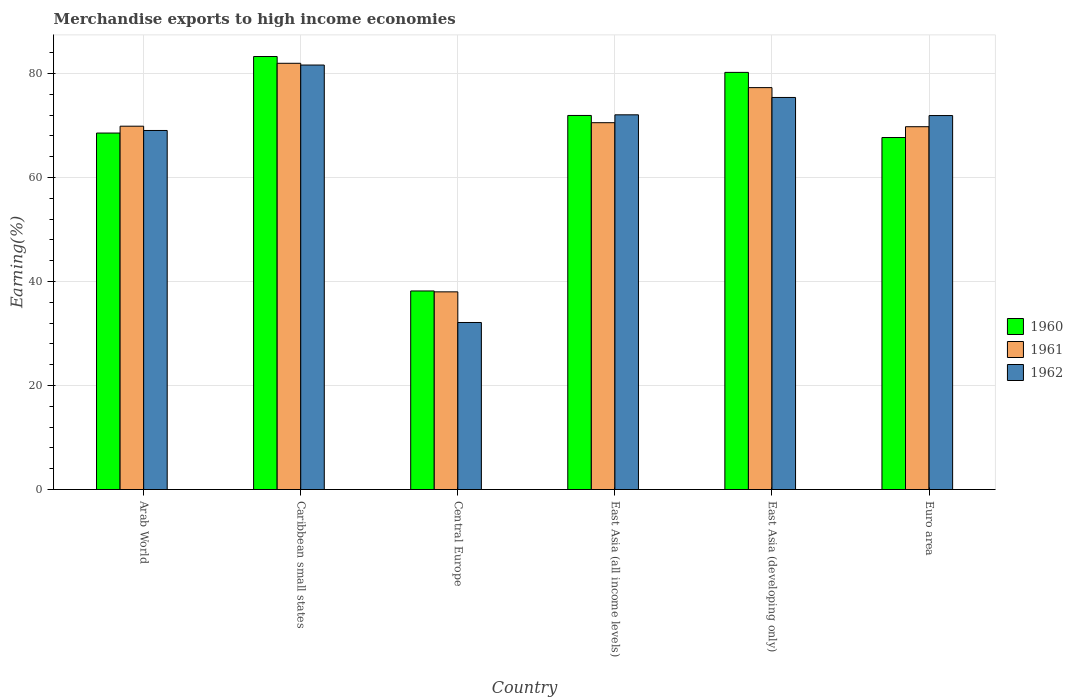How many different coloured bars are there?
Keep it short and to the point. 3. Are the number of bars per tick equal to the number of legend labels?
Keep it short and to the point. Yes. Are the number of bars on each tick of the X-axis equal?
Provide a short and direct response. Yes. How many bars are there on the 3rd tick from the left?
Offer a very short reply. 3. How many bars are there on the 3rd tick from the right?
Your answer should be very brief. 3. What is the label of the 5th group of bars from the left?
Provide a short and direct response. East Asia (developing only). What is the percentage of amount earned from merchandise exports in 1961 in Euro area?
Your answer should be compact. 69.78. Across all countries, what is the maximum percentage of amount earned from merchandise exports in 1960?
Keep it short and to the point. 83.28. Across all countries, what is the minimum percentage of amount earned from merchandise exports in 1962?
Your response must be concise. 32.12. In which country was the percentage of amount earned from merchandise exports in 1960 maximum?
Keep it short and to the point. Caribbean small states. In which country was the percentage of amount earned from merchandise exports in 1960 minimum?
Ensure brevity in your answer.  Central Europe. What is the total percentage of amount earned from merchandise exports in 1962 in the graph?
Ensure brevity in your answer.  402.21. What is the difference between the percentage of amount earned from merchandise exports in 1960 in Arab World and that in Caribbean small states?
Keep it short and to the point. -14.72. What is the difference between the percentage of amount earned from merchandise exports in 1960 in Arab World and the percentage of amount earned from merchandise exports in 1962 in East Asia (developing only)?
Give a very brief answer. -6.84. What is the average percentage of amount earned from merchandise exports in 1960 per country?
Your answer should be compact. 68.32. What is the difference between the percentage of amount earned from merchandise exports of/in 1962 and percentage of amount earned from merchandise exports of/in 1960 in Central Europe?
Offer a very short reply. -6.06. In how many countries, is the percentage of amount earned from merchandise exports in 1960 greater than 60 %?
Your response must be concise. 5. What is the ratio of the percentage of amount earned from merchandise exports in 1962 in East Asia (all income levels) to that in East Asia (developing only)?
Keep it short and to the point. 0.96. Is the difference between the percentage of amount earned from merchandise exports in 1962 in Arab World and East Asia (all income levels) greater than the difference between the percentage of amount earned from merchandise exports in 1960 in Arab World and East Asia (all income levels)?
Offer a terse response. Yes. What is the difference between the highest and the second highest percentage of amount earned from merchandise exports in 1960?
Your response must be concise. -3.05. What is the difference between the highest and the lowest percentage of amount earned from merchandise exports in 1960?
Make the answer very short. 45.09. In how many countries, is the percentage of amount earned from merchandise exports in 1961 greater than the average percentage of amount earned from merchandise exports in 1961 taken over all countries?
Offer a terse response. 5. What does the 1st bar from the left in Euro area represents?
Your response must be concise. 1960. How many bars are there?
Offer a terse response. 18. How many countries are there in the graph?
Provide a short and direct response. 6. Does the graph contain grids?
Offer a very short reply. Yes. How many legend labels are there?
Your answer should be compact. 3. What is the title of the graph?
Your answer should be very brief. Merchandise exports to high income economies. What is the label or title of the X-axis?
Your answer should be compact. Country. What is the label or title of the Y-axis?
Offer a very short reply. Earning(%). What is the Earning(%) in 1960 in Arab World?
Provide a succinct answer. 68.56. What is the Earning(%) of 1961 in Arab World?
Provide a short and direct response. 69.88. What is the Earning(%) of 1962 in Arab World?
Offer a terse response. 69.05. What is the Earning(%) of 1960 in Caribbean small states?
Your response must be concise. 83.28. What is the Earning(%) in 1961 in Caribbean small states?
Ensure brevity in your answer.  81.98. What is the Earning(%) in 1962 in Caribbean small states?
Offer a terse response. 81.64. What is the Earning(%) in 1960 in Central Europe?
Give a very brief answer. 38.19. What is the Earning(%) of 1961 in Central Europe?
Provide a short and direct response. 38.02. What is the Earning(%) in 1962 in Central Europe?
Offer a very short reply. 32.12. What is the Earning(%) of 1960 in East Asia (all income levels)?
Make the answer very short. 71.94. What is the Earning(%) of 1961 in East Asia (all income levels)?
Keep it short and to the point. 70.55. What is the Earning(%) of 1962 in East Asia (all income levels)?
Your response must be concise. 72.07. What is the Earning(%) of 1960 in East Asia (developing only)?
Offer a terse response. 80.23. What is the Earning(%) of 1961 in East Asia (developing only)?
Give a very brief answer. 77.3. What is the Earning(%) of 1962 in East Asia (developing only)?
Provide a short and direct response. 75.4. What is the Earning(%) of 1960 in Euro area?
Offer a terse response. 67.7. What is the Earning(%) in 1961 in Euro area?
Your response must be concise. 69.78. What is the Earning(%) in 1962 in Euro area?
Provide a short and direct response. 71.92. Across all countries, what is the maximum Earning(%) of 1960?
Your answer should be compact. 83.28. Across all countries, what is the maximum Earning(%) of 1961?
Offer a terse response. 81.98. Across all countries, what is the maximum Earning(%) in 1962?
Your answer should be very brief. 81.64. Across all countries, what is the minimum Earning(%) of 1960?
Ensure brevity in your answer.  38.19. Across all countries, what is the minimum Earning(%) of 1961?
Make the answer very short. 38.02. Across all countries, what is the minimum Earning(%) of 1962?
Make the answer very short. 32.12. What is the total Earning(%) in 1960 in the graph?
Offer a very short reply. 409.89. What is the total Earning(%) of 1961 in the graph?
Offer a very short reply. 407.5. What is the total Earning(%) in 1962 in the graph?
Make the answer very short. 402.21. What is the difference between the Earning(%) of 1960 in Arab World and that in Caribbean small states?
Make the answer very short. -14.72. What is the difference between the Earning(%) in 1961 in Arab World and that in Caribbean small states?
Offer a very short reply. -12.1. What is the difference between the Earning(%) of 1962 in Arab World and that in Caribbean small states?
Ensure brevity in your answer.  -12.58. What is the difference between the Earning(%) in 1960 in Arab World and that in Central Europe?
Provide a succinct answer. 30.37. What is the difference between the Earning(%) of 1961 in Arab World and that in Central Europe?
Provide a succinct answer. 31.86. What is the difference between the Earning(%) in 1962 in Arab World and that in Central Europe?
Offer a terse response. 36.93. What is the difference between the Earning(%) of 1960 in Arab World and that in East Asia (all income levels)?
Your answer should be very brief. -3.38. What is the difference between the Earning(%) in 1961 in Arab World and that in East Asia (all income levels)?
Your answer should be compact. -0.67. What is the difference between the Earning(%) in 1962 in Arab World and that in East Asia (all income levels)?
Offer a terse response. -3.01. What is the difference between the Earning(%) of 1960 in Arab World and that in East Asia (developing only)?
Provide a short and direct response. -11.67. What is the difference between the Earning(%) in 1961 in Arab World and that in East Asia (developing only)?
Your answer should be compact. -7.42. What is the difference between the Earning(%) in 1962 in Arab World and that in East Asia (developing only)?
Provide a short and direct response. -6.35. What is the difference between the Earning(%) of 1960 in Arab World and that in Euro area?
Keep it short and to the point. 0.86. What is the difference between the Earning(%) in 1961 in Arab World and that in Euro area?
Provide a succinct answer. 0.1. What is the difference between the Earning(%) of 1962 in Arab World and that in Euro area?
Provide a short and direct response. -2.87. What is the difference between the Earning(%) in 1960 in Caribbean small states and that in Central Europe?
Provide a succinct answer. 45.09. What is the difference between the Earning(%) in 1961 in Caribbean small states and that in Central Europe?
Ensure brevity in your answer.  43.96. What is the difference between the Earning(%) of 1962 in Caribbean small states and that in Central Europe?
Offer a terse response. 49.52. What is the difference between the Earning(%) in 1960 in Caribbean small states and that in East Asia (all income levels)?
Ensure brevity in your answer.  11.34. What is the difference between the Earning(%) in 1961 in Caribbean small states and that in East Asia (all income levels)?
Your response must be concise. 11.42. What is the difference between the Earning(%) in 1962 in Caribbean small states and that in East Asia (all income levels)?
Offer a terse response. 9.57. What is the difference between the Earning(%) of 1960 in Caribbean small states and that in East Asia (developing only)?
Keep it short and to the point. 3.05. What is the difference between the Earning(%) of 1961 in Caribbean small states and that in East Asia (developing only)?
Keep it short and to the point. 4.68. What is the difference between the Earning(%) of 1962 in Caribbean small states and that in East Asia (developing only)?
Ensure brevity in your answer.  6.23. What is the difference between the Earning(%) of 1960 in Caribbean small states and that in Euro area?
Make the answer very short. 15.58. What is the difference between the Earning(%) in 1961 in Caribbean small states and that in Euro area?
Your answer should be very brief. 12.2. What is the difference between the Earning(%) of 1962 in Caribbean small states and that in Euro area?
Offer a very short reply. 9.71. What is the difference between the Earning(%) in 1960 in Central Europe and that in East Asia (all income levels)?
Offer a terse response. -33.75. What is the difference between the Earning(%) of 1961 in Central Europe and that in East Asia (all income levels)?
Your response must be concise. -32.54. What is the difference between the Earning(%) in 1962 in Central Europe and that in East Asia (all income levels)?
Give a very brief answer. -39.94. What is the difference between the Earning(%) in 1960 in Central Europe and that in East Asia (developing only)?
Your answer should be very brief. -42.04. What is the difference between the Earning(%) of 1961 in Central Europe and that in East Asia (developing only)?
Your answer should be compact. -39.28. What is the difference between the Earning(%) in 1962 in Central Europe and that in East Asia (developing only)?
Your response must be concise. -43.28. What is the difference between the Earning(%) in 1960 in Central Europe and that in Euro area?
Provide a succinct answer. -29.51. What is the difference between the Earning(%) in 1961 in Central Europe and that in Euro area?
Give a very brief answer. -31.76. What is the difference between the Earning(%) of 1962 in Central Europe and that in Euro area?
Ensure brevity in your answer.  -39.8. What is the difference between the Earning(%) of 1960 in East Asia (all income levels) and that in East Asia (developing only)?
Your answer should be very brief. -8.29. What is the difference between the Earning(%) in 1961 in East Asia (all income levels) and that in East Asia (developing only)?
Provide a short and direct response. -6.75. What is the difference between the Earning(%) of 1962 in East Asia (all income levels) and that in East Asia (developing only)?
Give a very brief answer. -3.34. What is the difference between the Earning(%) of 1960 in East Asia (all income levels) and that in Euro area?
Your answer should be very brief. 4.24. What is the difference between the Earning(%) of 1961 in East Asia (all income levels) and that in Euro area?
Your response must be concise. 0.77. What is the difference between the Earning(%) in 1962 in East Asia (all income levels) and that in Euro area?
Your answer should be very brief. 0.14. What is the difference between the Earning(%) in 1960 in East Asia (developing only) and that in Euro area?
Your response must be concise. 12.53. What is the difference between the Earning(%) of 1961 in East Asia (developing only) and that in Euro area?
Your response must be concise. 7.52. What is the difference between the Earning(%) in 1962 in East Asia (developing only) and that in Euro area?
Offer a terse response. 3.48. What is the difference between the Earning(%) in 1960 in Arab World and the Earning(%) in 1961 in Caribbean small states?
Offer a very short reply. -13.42. What is the difference between the Earning(%) in 1960 in Arab World and the Earning(%) in 1962 in Caribbean small states?
Make the answer very short. -13.08. What is the difference between the Earning(%) in 1961 in Arab World and the Earning(%) in 1962 in Caribbean small states?
Ensure brevity in your answer.  -11.76. What is the difference between the Earning(%) of 1960 in Arab World and the Earning(%) of 1961 in Central Europe?
Ensure brevity in your answer.  30.54. What is the difference between the Earning(%) of 1960 in Arab World and the Earning(%) of 1962 in Central Europe?
Keep it short and to the point. 36.44. What is the difference between the Earning(%) of 1961 in Arab World and the Earning(%) of 1962 in Central Europe?
Your response must be concise. 37.76. What is the difference between the Earning(%) of 1960 in Arab World and the Earning(%) of 1961 in East Asia (all income levels)?
Provide a short and direct response. -1.99. What is the difference between the Earning(%) of 1960 in Arab World and the Earning(%) of 1962 in East Asia (all income levels)?
Give a very brief answer. -3.51. What is the difference between the Earning(%) in 1961 in Arab World and the Earning(%) in 1962 in East Asia (all income levels)?
Your response must be concise. -2.19. What is the difference between the Earning(%) of 1960 in Arab World and the Earning(%) of 1961 in East Asia (developing only)?
Make the answer very short. -8.74. What is the difference between the Earning(%) of 1960 in Arab World and the Earning(%) of 1962 in East Asia (developing only)?
Provide a short and direct response. -6.84. What is the difference between the Earning(%) in 1961 in Arab World and the Earning(%) in 1962 in East Asia (developing only)?
Offer a terse response. -5.53. What is the difference between the Earning(%) in 1960 in Arab World and the Earning(%) in 1961 in Euro area?
Your response must be concise. -1.22. What is the difference between the Earning(%) in 1960 in Arab World and the Earning(%) in 1962 in Euro area?
Ensure brevity in your answer.  -3.36. What is the difference between the Earning(%) of 1961 in Arab World and the Earning(%) of 1962 in Euro area?
Offer a very short reply. -2.05. What is the difference between the Earning(%) in 1960 in Caribbean small states and the Earning(%) in 1961 in Central Europe?
Make the answer very short. 45.26. What is the difference between the Earning(%) in 1960 in Caribbean small states and the Earning(%) in 1962 in Central Europe?
Make the answer very short. 51.15. What is the difference between the Earning(%) in 1961 in Caribbean small states and the Earning(%) in 1962 in Central Europe?
Provide a short and direct response. 49.85. What is the difference between the Earning(%) of 1960 in Caribbean small states and the Earning(%) of 1961 in East Asia (all income levels)?
Your response must be concise. 12.73. What is the difference between the Earning(%) of 1960 in Caribbean small states and the Earning(%) of 1962 in East Asia (all income levels)?
Provide a succinct answer. 11.21. What is the difference between the Earning(%) in 1961 in Caribbean small states and the Earning(%) in 1962 in East Asia (all income levels)?
Make the answer very short. 9.91. What is the difference between the Earning(%) of 1960 in Caribbean small states and the Earning(%) of 1961 in East Asia (developing only)?
Keep it short and to the point. 5.98. What is the difference between the Earning(%) in 1960 in Caribbean small states and the Earning(%) in 1962 in East Asia (developing only)?
Provide a succinct answer. 7.87. What is the difference between the Earning(%) of 1961 in Caribbean small states and the Earning(%) of 1962 in East Asia (developing only)?
Your answer should be compact. 6.57. What is the difference between the Earning(%) in 1960 in Caribbean small states and the Earning(%) in 1961 in Euro area?
Your answer should be very brief. 13.5. What is the difference between the Earning(%) of 1960 in Caribbean small states and the Earning(%) of 1962 in Euro area?
Give a very brief answer. 11.35. What is the difference between the Earning(%) of 1961 in Caribbean small states and the Earning(%) of 1962 in Euro area?
Make the answer very short. 10.05. What is the difference between the Earning(%) of 1960 in Central Europe and the Earning(%) of 1961 in East Asia (all income levels)?
Your answer should be compact. -32.36. What is the difference between the Earning(%) in 1960 in Central Europe and the Earning(%) in 1962 in East Asia (all income levels)?
Your response must be concise. -33.88. What is the difference between the Earning(%) of 1961 in Central Europe and the Earning(%) of 1962 in East Asia (all income levels)?
Provide a succinct answer. -34.05. What is the difference between the Earning(%) of 1960 in Central Europe and the Earning(%) of 1961 in East Asia (developing only)?
Offer a very short reply. -39.11. What is the difference between the Earning(%) in 1960 in Central Europe and the Earning(%) in 1962 in East Asia (developing only)?
Offer a very short reply. -37.22. What is the difference between the Earning(%) of 1961 in Central Europe and the Earning(%) of 1962 in East Asia (developing only)?
Your answer should be very brief. -37.39. What is the difference between the Earning(%) in 1960 in Central Europe and the Earning(%) in 1961 in Euro area?
Offer a very short reply. -31.59. What is the difference between the Earning(%) of 1960 in Central Europe and the Earning(%) of 1962 in Euro area?
Provide a succinct answer. -33.74. What is the difference between the Earning(%) of 1961 in Central Europe and the Earning(%) of 1962 in Euro area?
Ensure brevity in your answer.  -33.91. What is the difference between the Earning(%) of 1960 in East Asia (all income levels) and the Earning(%) of 1961 in East Asia (developing only)?
Ensure brevity in your answer.  -5.36. What is the difference between the Earning(%) of 1960 in East Asia (all income levels) and the Earning(%) of 1962 in East Asia (developing only)?
Make the answer very short. -3.46. What is the difference between the Earning(%) in 1961 in East Asia (all income levels) and the Earning(%) in 1962 in East Asia (developing only)?
Give a very brief answer. -4.85. What is the difference between the Earning(%) of 1960 in East Asia (all income levels) and the Earning(%) of 1961 in Euro area?
Make the answer very short. 2.16. What is the difference between the Earning(%) in 1960 in East Asia (all income levels) and the Earning(%) in 1962 in Euro area?
Keep it short and to the point. 0.02. What is the difference between the Earning(%) in 1961 in East Asia (all income levels) and the Earning(%) in 1962 in Euro area?
Offer a terse response. -1.37. What is the difference between the Earning(%) of 1960 in East Asia (developing only) and the Earning(%) of 1961 in Euro area?
Your response must be concise. 10.45. What is the difference between the Earning(%) in 1960 in East Asia (developing only) and the Earning(%) in 1962 in Euro area?
Provide a short and direct response. 8.3. What is the difference between the Earning(%) of 1961 in East Asia (developing only) and the Earning(%) of 1962 in Euro area?
Ensure brevity in your answer.  5.37. What is the average Earning(%) in 1960 per country?
Offer a terse response. 68.32. What is the average Earning(%) in 1961 per country?
Offer a terse response. 67.92. What is the average Earning(%) in 1962 per country?
Provide a short and direct response. 67.03. What is the difference between the Earning(%) in 1960 and Earning(%) in 1961 in Arab World?
Offer a very short reply. -1.32. What is the difference between the Earning(%) in 1960 and Earning(%) in 1962 in Arab World?
Your answer should be compact. -0.49. What is the difference between the Earning(%) in 1961 and Earning(%) in 1962 in Arab World?
Your answer should be very brief. 0.82. What is the difference between the Earning(%) of 1960 and Earning(%) of 1961 in Caribbean small states?
Your response must be concise. 1.3. What is the difference between the Earning(%) of 1960 and Earning(%) of 1962 in Caribbean small states?
Provide a short and direct response. 1.64. What is the difference between the Earning(%) in 1961 and Earning(%) in 1962 in Caribbean small states?
Keep it short and to the point. 0.34. What is the difference between the Earning(%) in 1960 and Earning(%) in 1961 in Central Europe?
Offer a terse response. 0.17. What is the difference between the Earning(%) of 1960 and Earning(%) of 1962 in Central Europe?
Ensure brevity in your answer.  6.07. What is the difference between the Earning(%) in 1961 and Earning(%) in 1962 in Central Europe?
Give a very brief answer. 5.89. What is the difference between the Earning(%) of 1960 and Earning(%) of 1961 in East Asia (all income levels)?
Your answer should be very brief. 1.39. What is the difference between the Earning(%) of 1960 and Earning(%) of 1962 in East Asia (all income levels)?
Keep it short and to the point. -0.13. What is the difference between the Earning(%) in 1961 and Earning(%) in 1962 in East Asia (all income levels)?
Offer a very short reply. -1.51. What is the difference between the Earning(%) of 1960 and Earning(%) of 1961 in East Asia (developing only)?
Your response must be concise. 2.93. What is the difference between the Earning(%) of 1960 and Earning(%) of 1962 in East Asia (developing only)?
Provide a succinct answer. 4.82. What is the difference between the Earning(%) in 1961 and Earning(%) in 1962 in East Asia (developing only)?
Keep it short and to the point. 1.89. What is the difference between the Earning(%) of 1960 and Earning(%) of 1961 in Euro area?
Provide a short and direct response. -2.08. What is the difference between the Earning(%) of 1960 and Earning(%) of 1962 in Euro area?
Offer a terse response. -4.23. What is the difference between the Earning(%) of 1961 and Earning(%) of 1962 in Euro area?
Keep it short and to the point. -2.14. What is the ratio of the Earning(%) in 1960 in Arab World to that in Caribbean small states?
Your response must be concise. 0.82. What is the ratio of the Earning(%) of 1961 in Arab World to that in Caribbean small states?
Give a very brief answer. 0.85. What is the ratio of the Earning(%) in 1962 in Arab World to that in Caribbean small states?
Give a very brief answer. 0.85. What is the ratio of the Earning(%) in 1960 in Arab World to that in Central Europe?
Provide a short and direct response. 1.8. What is the ratio of the Earning(%) in 1961 in Arab World to that in Central Europe?
Provide a succinct answer. 1.84. What is the ratio of the Earning(%) in 1962 in Arab World to that in Central Europe?
Provide a short and direct response. 2.15. What is the ratio of the Earning(%) of 1960 in Arab World to that in East Asia (all income levels)?
Keep it short and to the point. 0.95. What is the ratio of the Earning(%) of 1962 in Arab World to that in East Asia (all income levels)?
Your response must be concise. 0.96. What is the ratio of the Earning(%) in 1960 in Arab World to that in East Asia (developing only)?
Offer a terse response. 0.85. What is the ratio of the Earning(%) in 1961 in Arab World to that in East Asia (developing only)?
Ensure brevity in your answer.  0.9. What is the ratio of the Earning(%) of 1962 in Arab World to that in East Asia (developing only)?
Your answer should be compact. 0.92. What is the ratio of the Earning(%) in 1960 in Arab World to that in Euro area?
Offer a very short reply. 1.01. What is the ratio of the Earning(%) in 1962 in Arab World to that in Euro area?
Offer a terse response. 0.96. What is the ratio of the Earning(%) in 1960 in Caribbean small states to that in Central Europe?
Your answer should be very brief. 2.18. What is the ratio of the Earning(%) of 1961 in Caribbean small states to that in Central Europe?
Ensure brevity in your answer.  2.16. What is the ratio of the Earning(%) of 1962 in Caribbean small states to that in Central Europe?
Offer a very short reply. 2.54. What is the ratio of the Earning(%) in 1960 in Caribbean small states to that in East Asia (all income levels)?
Offer a very short reply. 1.16. What is the ratio of the Earning(%) of 1961 in Caribbean small states to that in East Asia (all income levels)?
Your answer should be compact. 1.16. What is the ratio of the Earning(%) of 1962 in Caribbean small states to that in East Asia (all income levels)?
Your answer should be very brief. 1.13. What is the ratio of the Earning(%) in 1960 in Caribbean small states to that in East Asia (developing only)?
Offer a very short reply. 1.04. What is the ratio of the Earning(%) in 1961 in Caribbean small states to that in East Asia (developing only)?
Ensure brevity in your answer.  1.06. What is the ratio of the Earning(%) of 1962 in Caribbean small states to that in East Asia (developing only)?
Offer a very short reply. 1.08. What is the ratio of the Earning(%) of 1960 in Caribbean small states to that in Euro area?
Keep it short and to the point. 1.23. What is the ratio of the Earning(%) in 1961 in Caribbean small states to that in Euro area?
Keep it short and to the point. 1.17. What is the ratio of the Earning(%) of 1962 in Caribbean small states to that in Euro area?
Make the answer very short. 1.14. What is the ratio of the Earning(%) in 1960 in Central Europe to that in East Asia (all income levels)?
Your response must be concise. 0.53. What is the ratio of the Earning(%) in 1961 in Central Europe to that in East Asia (all income levels)?
Offer a terse response. 0.54. What is the ratio of the Earning(%) of 1962 in Central Europe to that in East Asia (all income levels)?
Your answer should be compact. 0.45. What is the ratio of the Earning(%) of 1960 in Central Europe to that in East Asia (developing only)?
Your answer should be very brief. 0.48. What is the ratio of the Earning(%) in 1961 in Central Europe to that in East Asia (developing only)?
Keep it short and to the point. 0.49. What is the ratio of the Earning(%) in 1962 in Central Europe to that in East Asia (developing only)?
Make the answer very short. 0.43. What is the ratio of the Earning(%) in 1960 in Central Europe to that in Euro area?
Your response must be concise. 0.56. What is the ratio of the Earning(%) of 1961 in Central Europe to that in Euro area?
Your answer should be compact. 0.54. What is the ratio of the Earning(%) in 1962 in Central Europe to that in Euro area?
Your answer should be very brief. 0.45. What is the ratio of the Earning(%) of 1960 in East Asia (all income levels) to that in East Asia (developing only)?
Make the answer very short. 0.9. What is the ratio of the Earning(%) in 1961 in East Asia (all income levels) to that in East Asia (developing only)?
Provide a short and direct response. 0.91. What is the ratio of the Earning(%) of 1962 in East Asia (all income levels) to that in East Asia (developing only)?
Provide a succinct answer. 0.96. What is the ratio of the Earning(%) of 1960 in East Asia (all income levels) to that in Euro area?
Keep it short and to the point. 1.06. What is the ratio of the Earning(%) in 1961 in East Asia (all income levels) to that in Euro area?
Make the answer very short. 1.01. What is the ratio of the Earning(%) in 1962 in East Asia (all income levels) to that in Euro area?
Provide a succinct answer. 1. What is the ratio of the Earning(%) of 1960 in East Asia (developing only) to that in Euro area?
Your answer should be compact. 1.19. What is the ratio of the Earning(%) in 1961 in East Asia (developing only) to that in Euro area?
Your answer should be compact. 1.11. What is the ratio of the Earning(%) of 1962 in East Asia (developing only) to that in Euro area?
Offer a terse response. 1.05. What is the difference between the highest and the second highest Earning(%) in 1960?
Keep it short and to the point. 3.05. What is the difference between the highest and the second highest Earning(%) in 1961?
Ensure brevity in your answer.  4.68. What is the difference between the highest and the second highest Earning(%) in 1962?
Your answer should be very brief. 6.23. What is the difference between the highest and the lowest Earning(%) in 1960?
Your response must be concise. 45.09. What is the difference between the highest and the lowest Earning(%) in 1961?
Your response must be concise. 43.96. What is the difference between the highest and the lowest Earning(%) in 1962?
Keep it short and to the point. 49.52. 